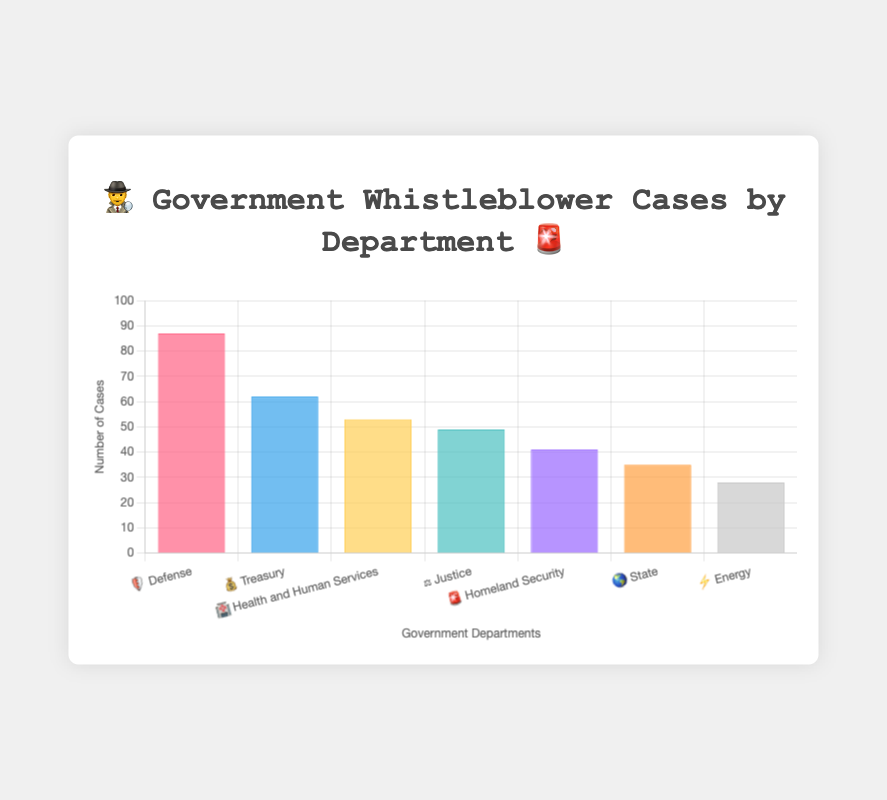Which department has the highest number of whistleblower cases? The department with the highest bar represents the highest number of cases. The Defense department, represented by the 🛡️ emoji, has the highest value on the y-axis.
Answer: Defense What is the total number of whistleblower cases in the Defense and Treasury departments? Add the number of cases for the Defense department (87) and the Treasury department (62). 87 + 62 = 149
Answer: 149 How many more cases does the Defense department have compared to the State department? Subtract the number of cases in the State department (35) from the number of cases in the Defense department (87). 87 - 35 = 52
Answer: 52 Which department has fewer cases, Justice department or Homeland Security department? Compare the number of cases: Justice department (49) vs. Homeland Security department (41). Since 41 < 49, Homeland Security has fewer cases.
Answer: Homeland Security Rank the departments in order of the number of whistleblower cases from highest to lowest. Order the departments by their corresponding cases: Defense (87), Treasury (62), Health and Human Services (53), Justice (49), Homeland Security (41), State (35), and Energy (28).
Answer: Defense, Treasury, Health and Human Services, Justice, Homeland Security, State, Energy What percentage of the total cases does the Health and Human Services department account for? Calculate the total cases (87 + 62 + 53 + 49 + 41 + 35 + 28 = 355) and find the percentage for Health and Human Services: (53 / 355) * 100 ≈ 14.93%
Answer: 14.93% By how many cases does the Treasury department exceed the Energy department? Subtract the number of cases in the Energy department (28) from the number of cases in the Treasury department (62). 62 - 28 = 34
Answer: 34 If the cases are divided equally among Defense, Treasury, and State departments, how many cases would each have? Sum the number of cases in these departments (87 + 62 + 35 = 184) and divide by 3. 184 / 3 ≈ 61.33
Answer: 61.33 Which departments have more than 50 cases? Identify departments with cases greater than 50. Defense (87), Treasury (62), and Health and Human Services (53) all have more than 50 cases.
Answer: Defense, Treasury, Health and Human Services 